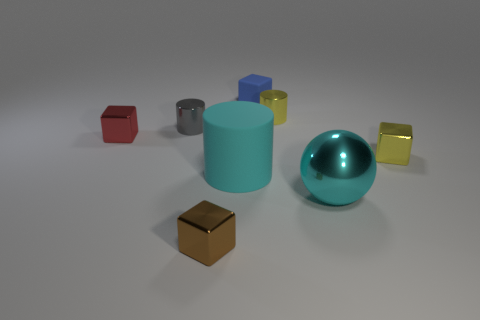Subtract 1 cubes. How many cubes are left? 3 Add 2 brown balls. How many objects exist? 10 Subtract all spheres. How many objects are left? 7 Subtract all cyan rubber things. Subtract all tiny gray cylinders. How many objects are left? 6 Add 6 rubber cylinders. How many rubber cylinders are left? 7 Add 3 large objects. How many large objects exist? 5 Subtract 1 yellow cubes. How many objects are left? 7 